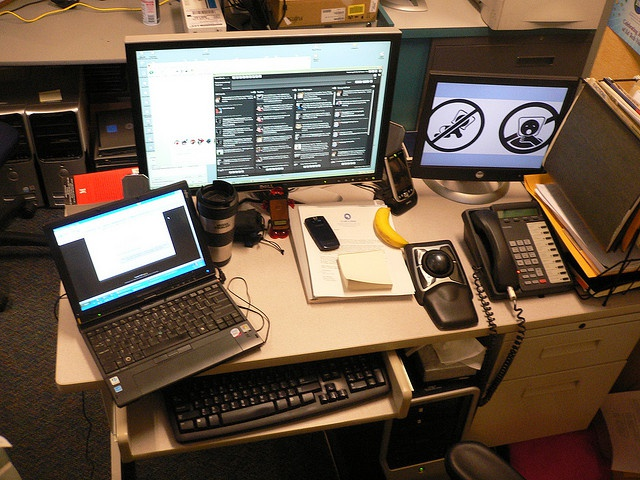Describe the objects in this image and their specific colors. I can see tv in gray, white, black, and darkgray tones, laptop in gray, black, white, and maroon tones, tv in gray, black, lavender, and darkgray tones, keyboard in gray, black, and maroon tones, and mouse in gray, black, and maroon tones in this image. 